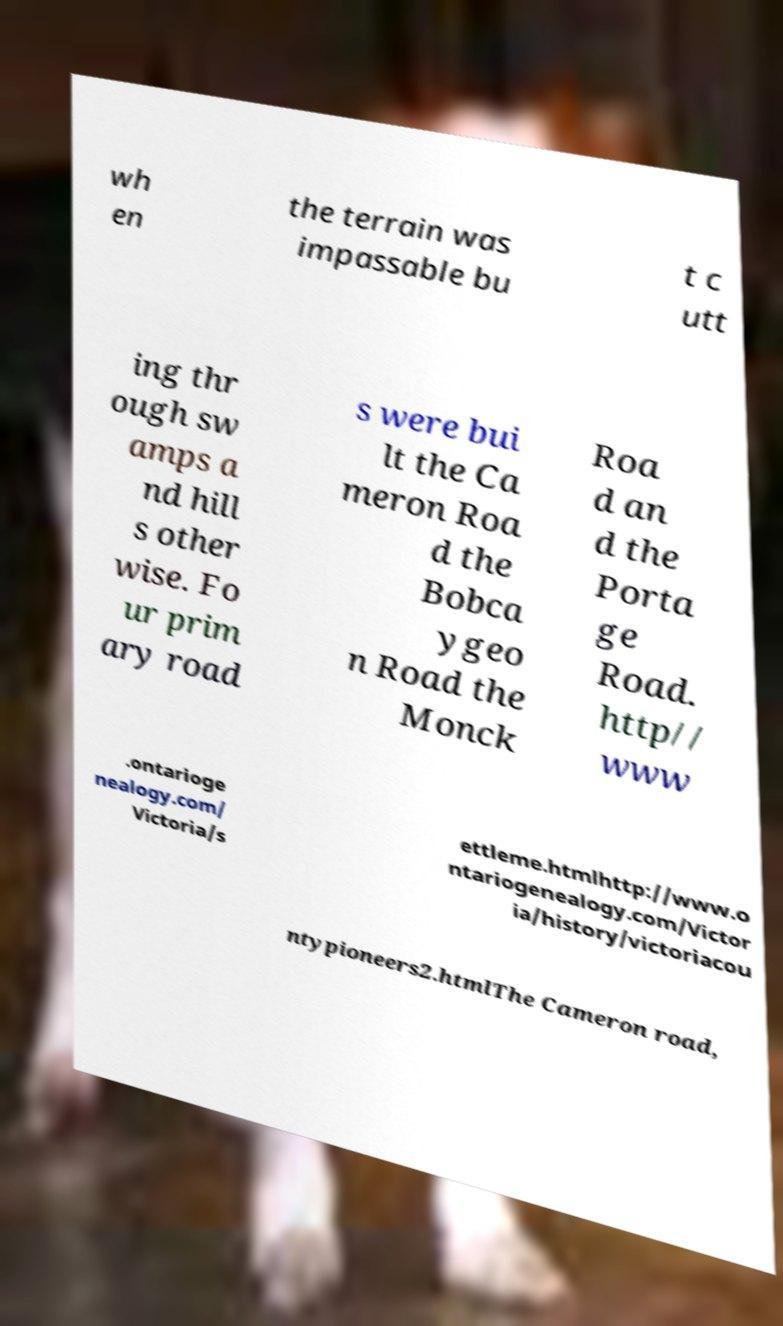Please read and relay the text visible in this image. What does it say? wh en the terrain was impassable bu t c utt ing thr ough sw amps a nd hill s other wise. Fo ur prim ary road s were bui lt the Ca meron Roa d the Bobca ygeo n Road the Monck Roa d an d the Porta ge Road. http// www .ontarioge nealogy.com/ Victoria/s ettleme.htmlhttp://www.o ntariogenealogy.com/Victor ia/history/victoriacou ntypioneers2.htmlThe Cameron road, 